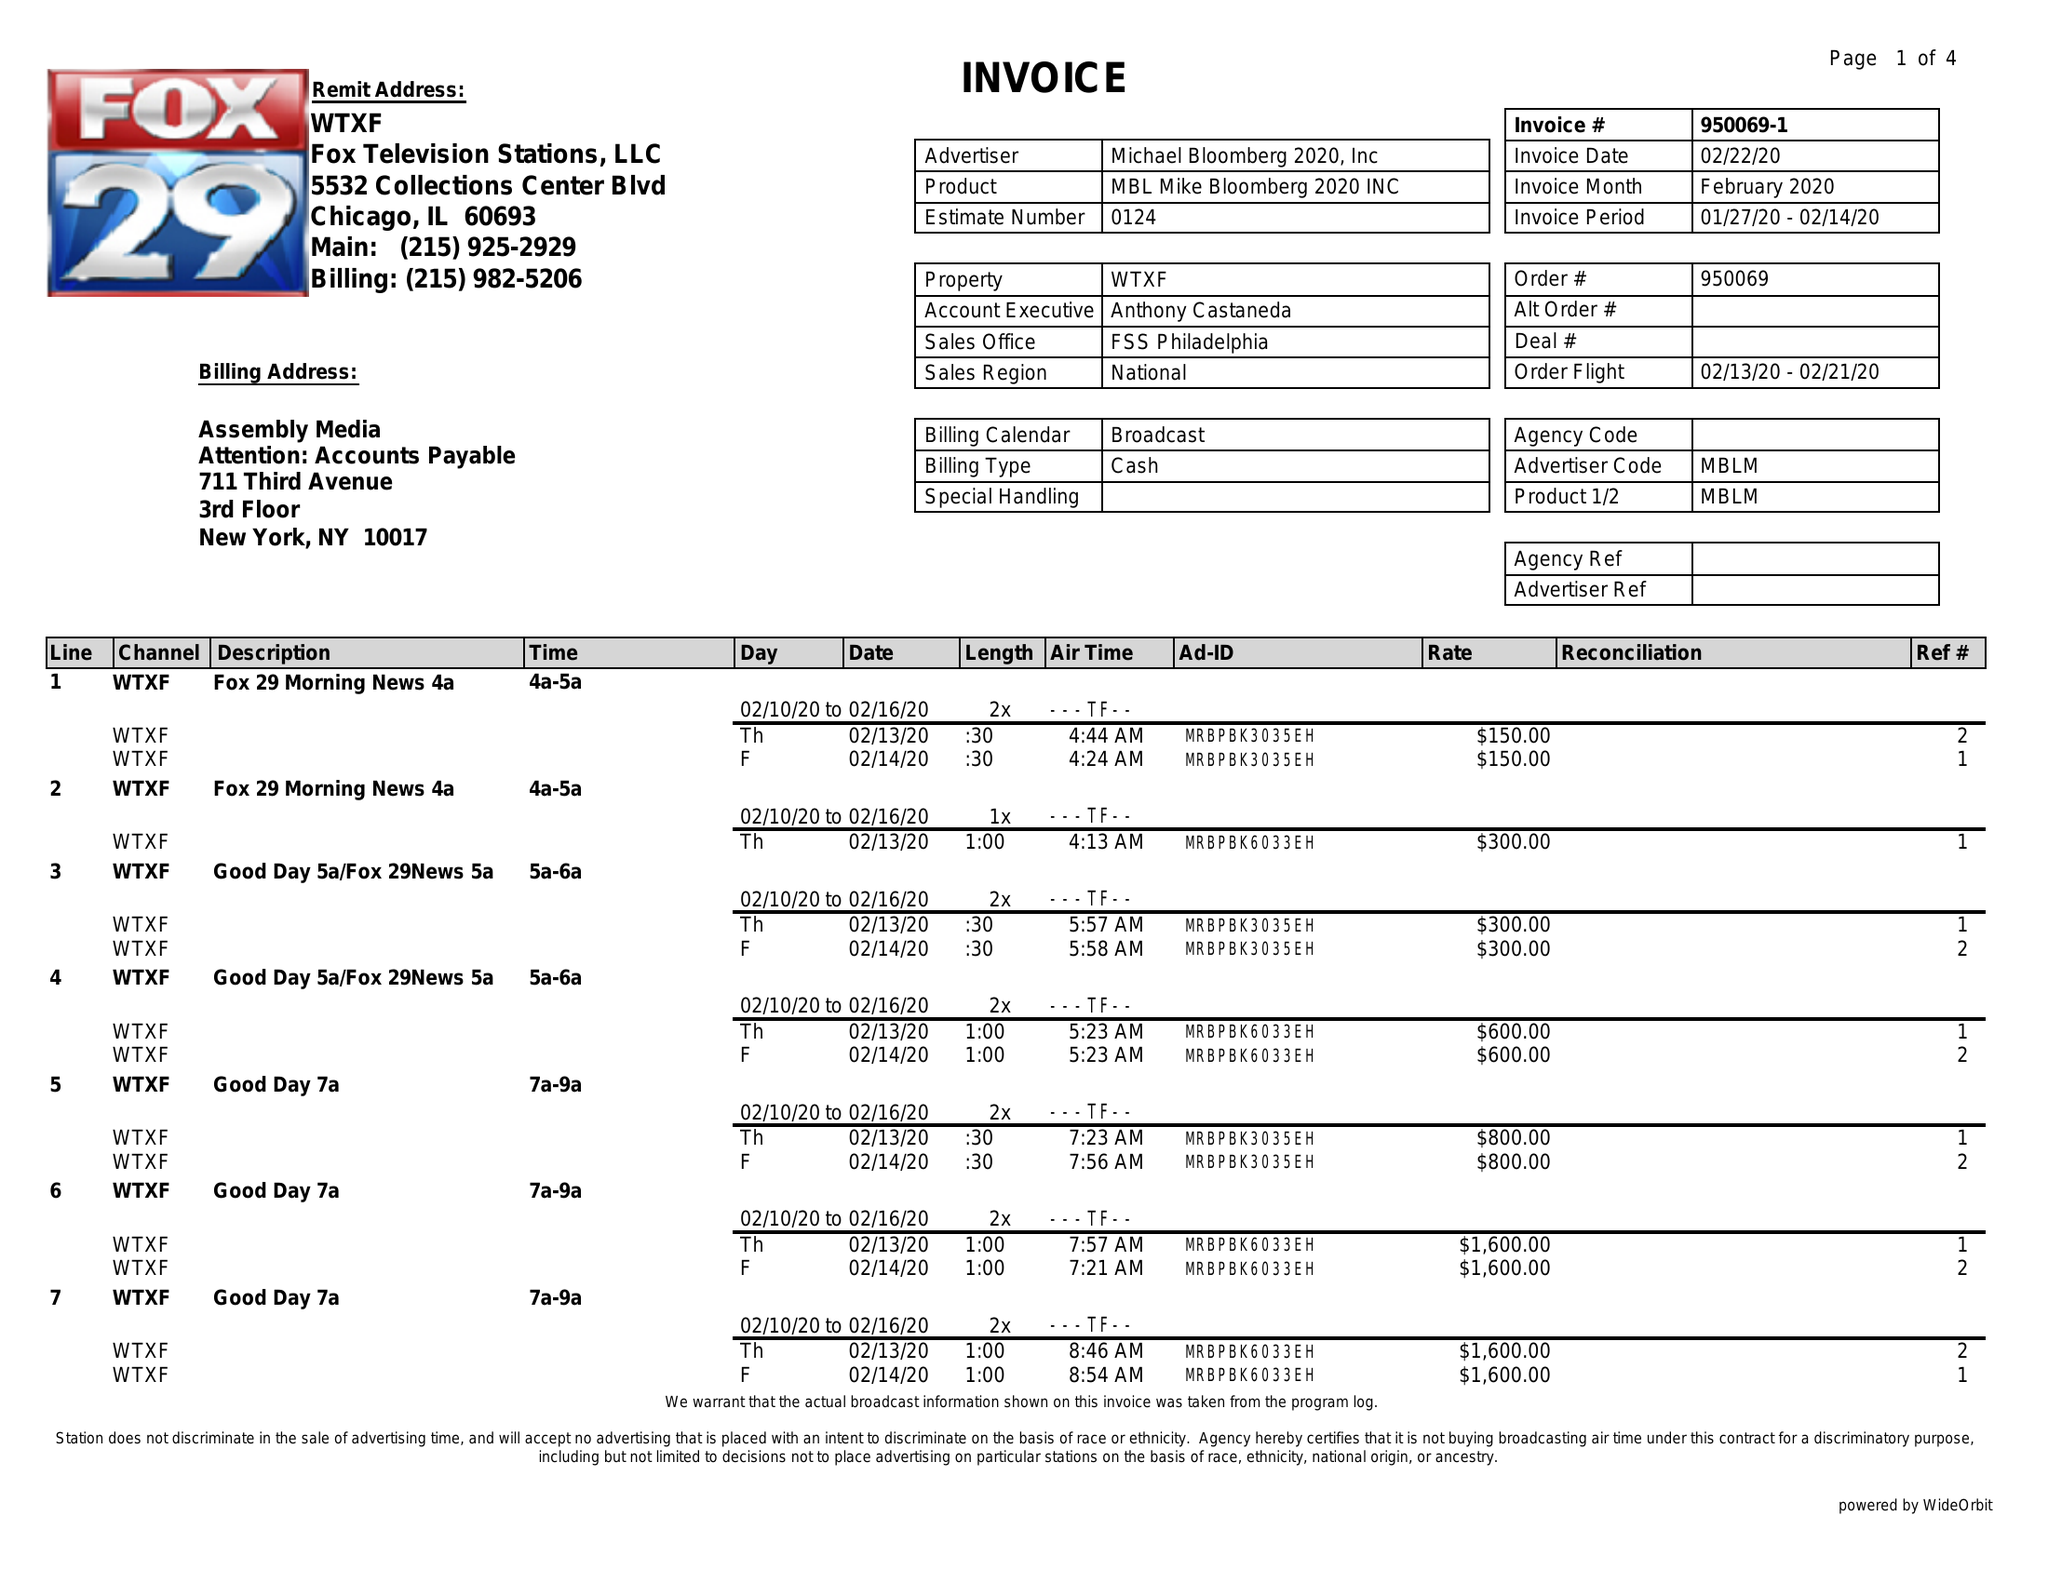What is the value for the flight_to?
Answer the question using a single word or phrase. 02/21/20 